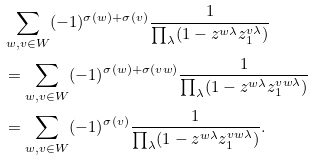Convert formula to latex. <formula><loc_0><loc_0><loc_500><loc_500>& \sum _ { w , v \in W } ( - 1 ) ^ { \sigma ( w ) + \sigma ( v ) } \frac { 1 } { \prod _ { \lambda } ( 1 - z ^ { w \lambda } z _ { 1 } ^ { v \lambda } ) } \\ & = \sum _ { w , v \in W } ( - 1 ) ^ { \sigma ( w ) + \sigma ( v w ) } \frac { 1 } { \prod _ { \lambda } ( 1 - z ^ { w \lambda } z _ { 1 } ^ { v w \lambda } ) } \\ & = \sum _ { w , v \in W } ( - 1 ) ^ { \sigma ( v ) } \frac { 1 } { \prod _ { \lambda } ( 1 - z ^ { w \lambda } z _ { 1 } ^ { v w \lambda } ) } .</formula> 